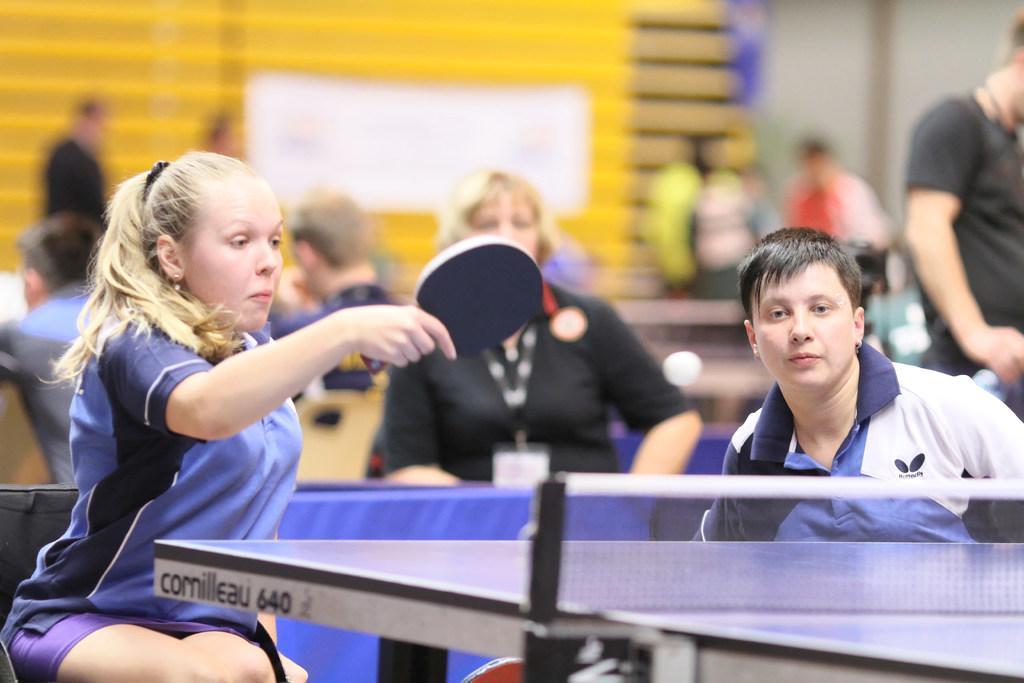How would you summarize this image in a sentence or two? The woman in the blue T-shirt is holding a tennis bat in her hand. I think she is playing table tennis. In front of her, we see a tennis table. On the right side, we see the woman in blue and white T-shirt is sitting on the chair. Behind them, we see people are standing. In the background, we see a wall in yellow color and it is blurred in the background. This picture might be clicked in the tennis court. 